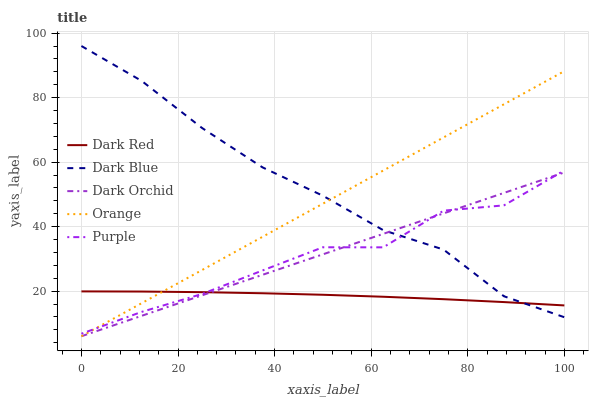Does Purple have the minimum area under the curve?
Answer yes or no. No. Does Purple have the maximum area under the curve?
Answer yes or no. No. Is Dark Red the smoothest?
Answer yes or no. No. Is Dark Red the roughest?
Answer yes or no. No. Does Purple have the lowest value?
Answer yes or no. No. Does Purple have the highest value?
Answer yes or no. No. 